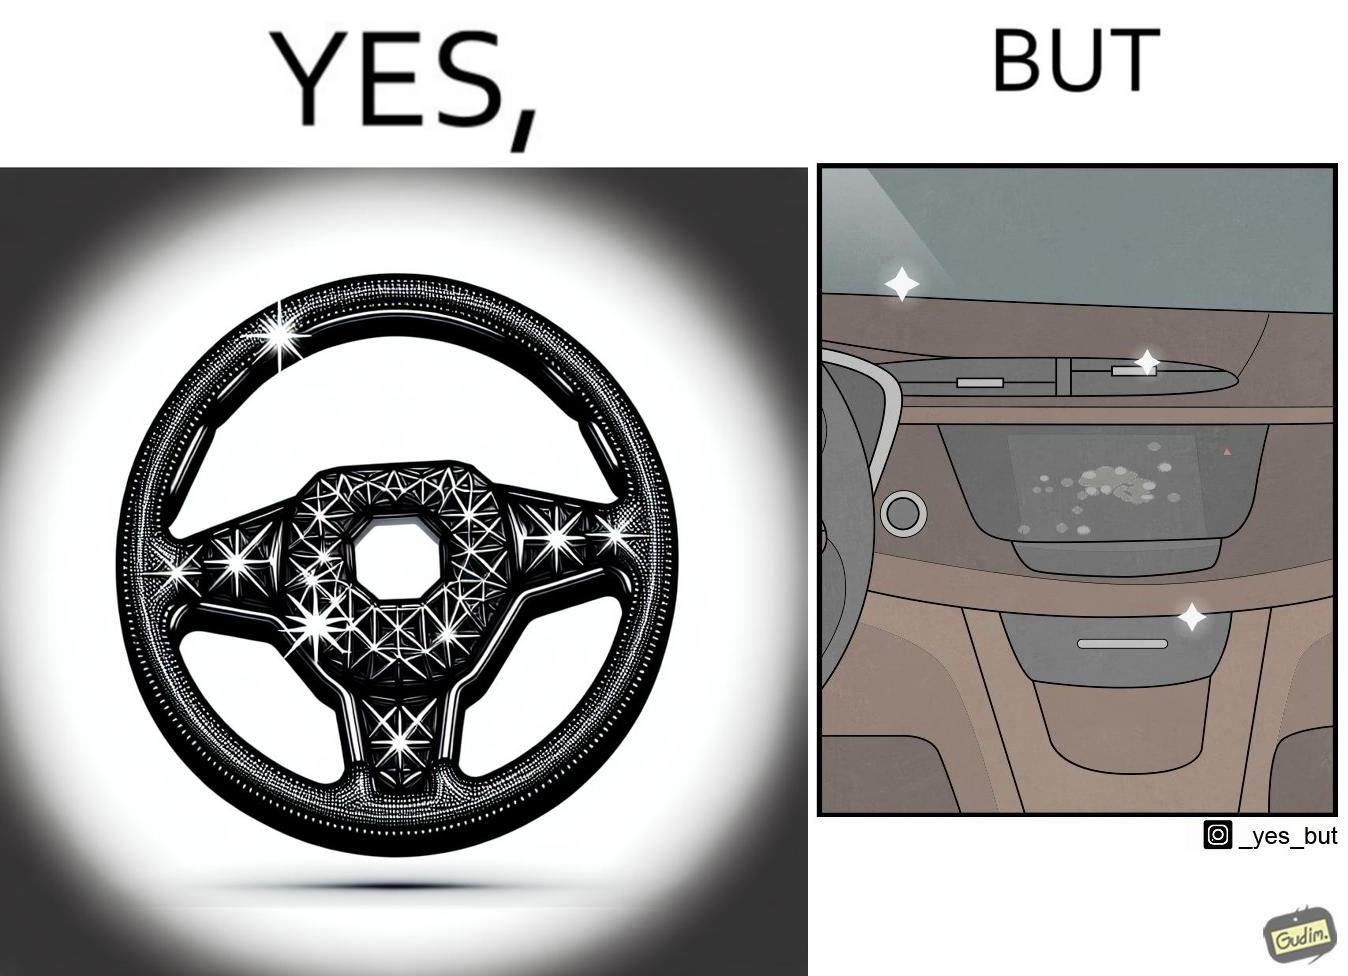Provide a description of this image. The dashboard and steering wheel of the car look sparkling clean, but the greasy fingerprints on the touch panel reduce the appeal of the dashboard. 